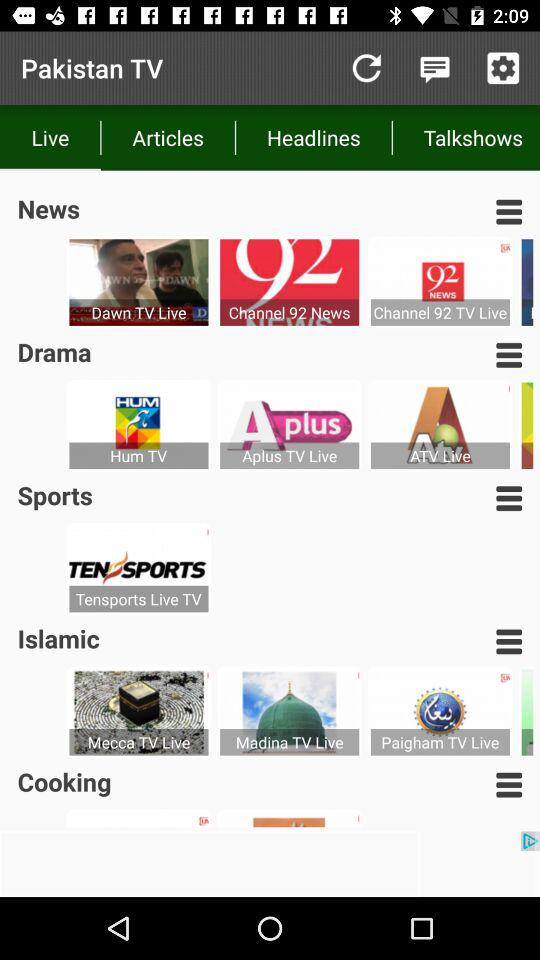When was the most recent sports article posted?
When the provided information is insufficient, respond with <no answer>. <no answer> 